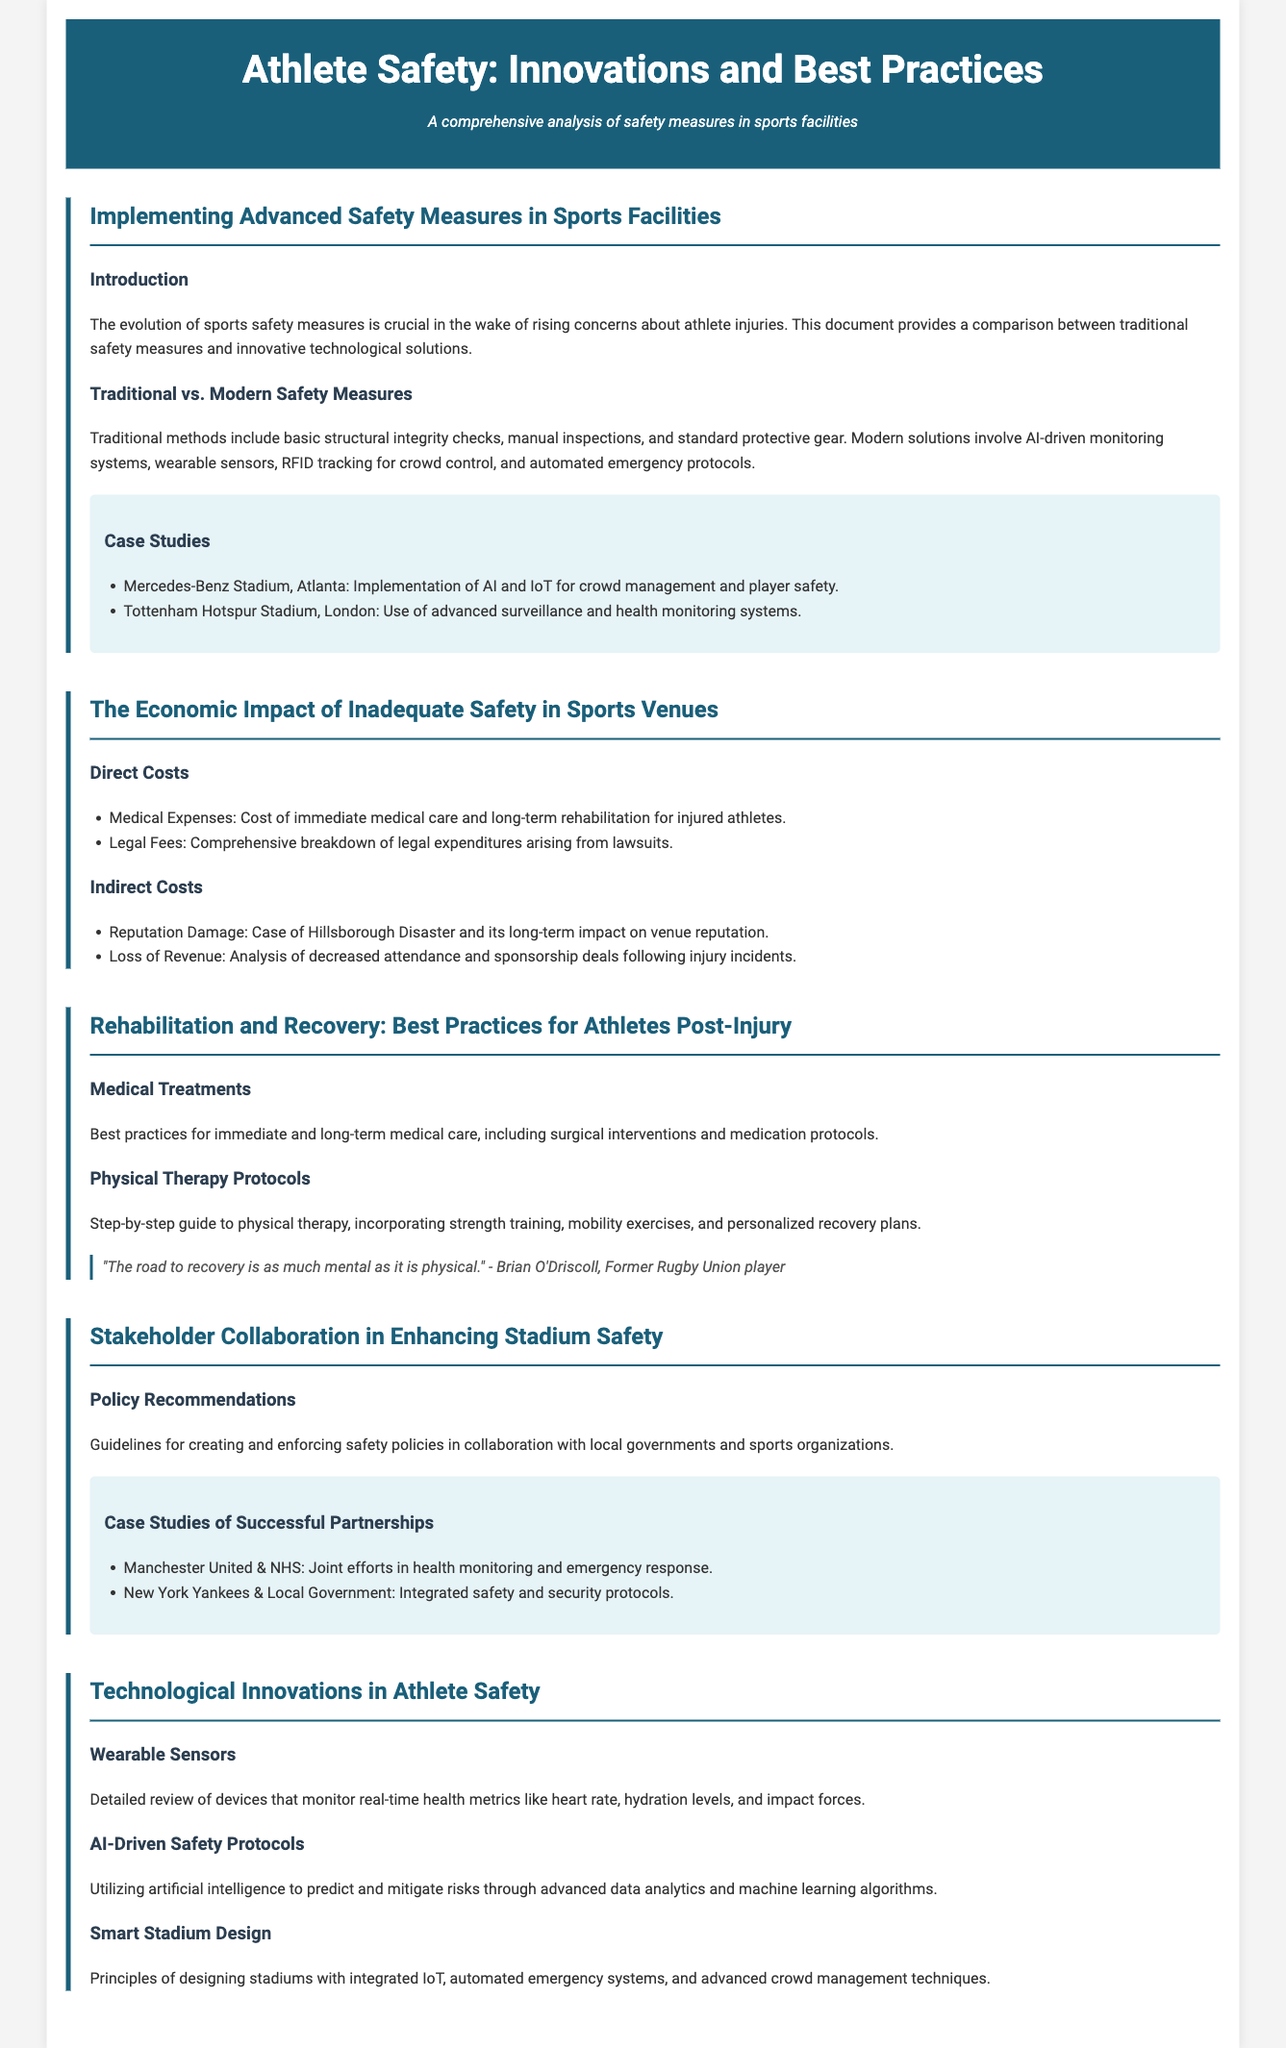what are some advanced safety measures mentioned? The document discusses AI-driven monitoring systems, wearable sensors, RFID tracking for crowd control, and automated emergency protocols as advanced safety measures.
Answer: AI-driven monitoring systems, wearable sensors, RFID tracking, automated emergency protocols which stadium implemented AI and IoT for crowd management? The case study provided in the document states that the Mercedes-Benz Stadium in Atlanta implemented AI and IoT for crowd management and player safety.
Answer: Mercedes-Benz Stadium, Atlanta what are the two types of costs associated with inadequate safety? The document outlines direct costs and indirect costs as types associated with inadequate safety in sports venues.
Answer: direct costs, indirect costs who is quoted regarding recovery being mental as well as physical? The whitepaper features a quote from Brian O'Driscoll, who emphasizes that recovery involves mental aspects as much as physical ones.
Answer: Brian O'Driscoll which two organizations collaborated on health monitoring and emergency response? The document describes a collaboration between Manchester United and the NHS for health monitoring and emergency response.
Answer: Manchester United & NHS what is one direct cost of inadequate safety mentioned? The document lists medical expenses as a direct cost associated with inadequate safety in sports venues.
Answer: medical expenses what technology is utilized for predicting and mitigating risks? The whitepaper mentions using AI-driven safety protocols to predict and mitigate risks.
Answer: AI-driven safety protocols what is the focus of the document? The overall focus of the document is on athlete safety and the innovations and best practices related to it.
Answer: athlete safety, innovations and best practices 